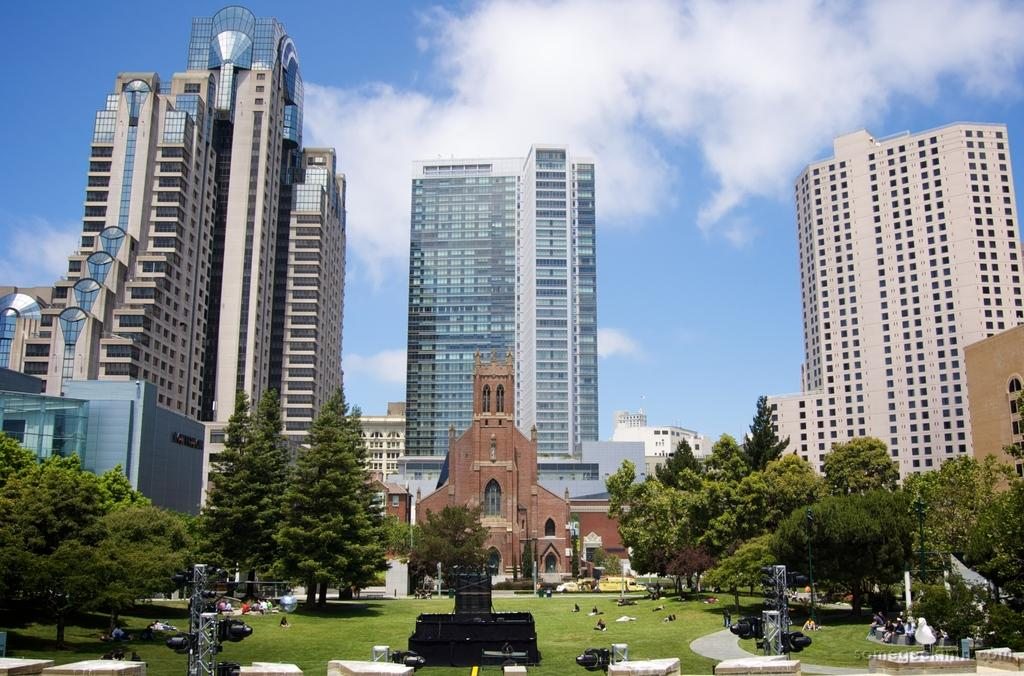What type of structures can be seen in the image? There are buildings in the image. What other natural elements are present in the image? There are trees in the image. Can you describe the people in the image? There are persons visible on the ground in the image. What is visible at the top of the image of the image? The sky is visible at the top of the image. What letters are visible on the buildings in the image? There is no mention of letters on the buildings in the provided facts, so we cannot determine if any letters are visible. How does the expansion of the buildings affect the surrounding environment in the image? The provided facts do not mention any expansion of the buildings, so we cannot determine its effect on the surrounding environment. 